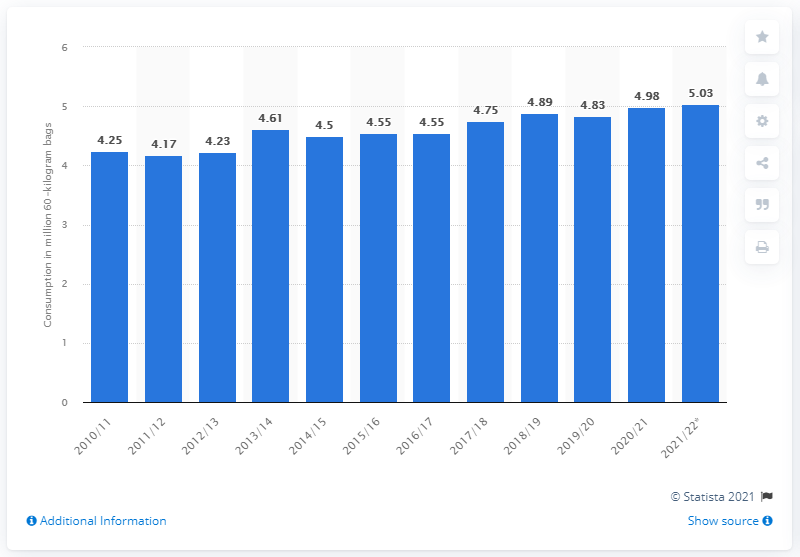Highlight a few significant elements in this photo. It is estimated that approximately 5.03 million 60-kilogram bags of coffee will be consumed in Canada during the 12-month marketing year ending in October 2022. 